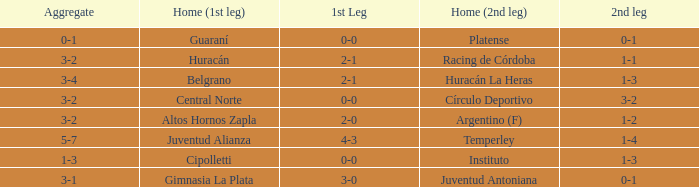Who played at home for the 2nd leg with a score of 1-2? Argentino (F). 